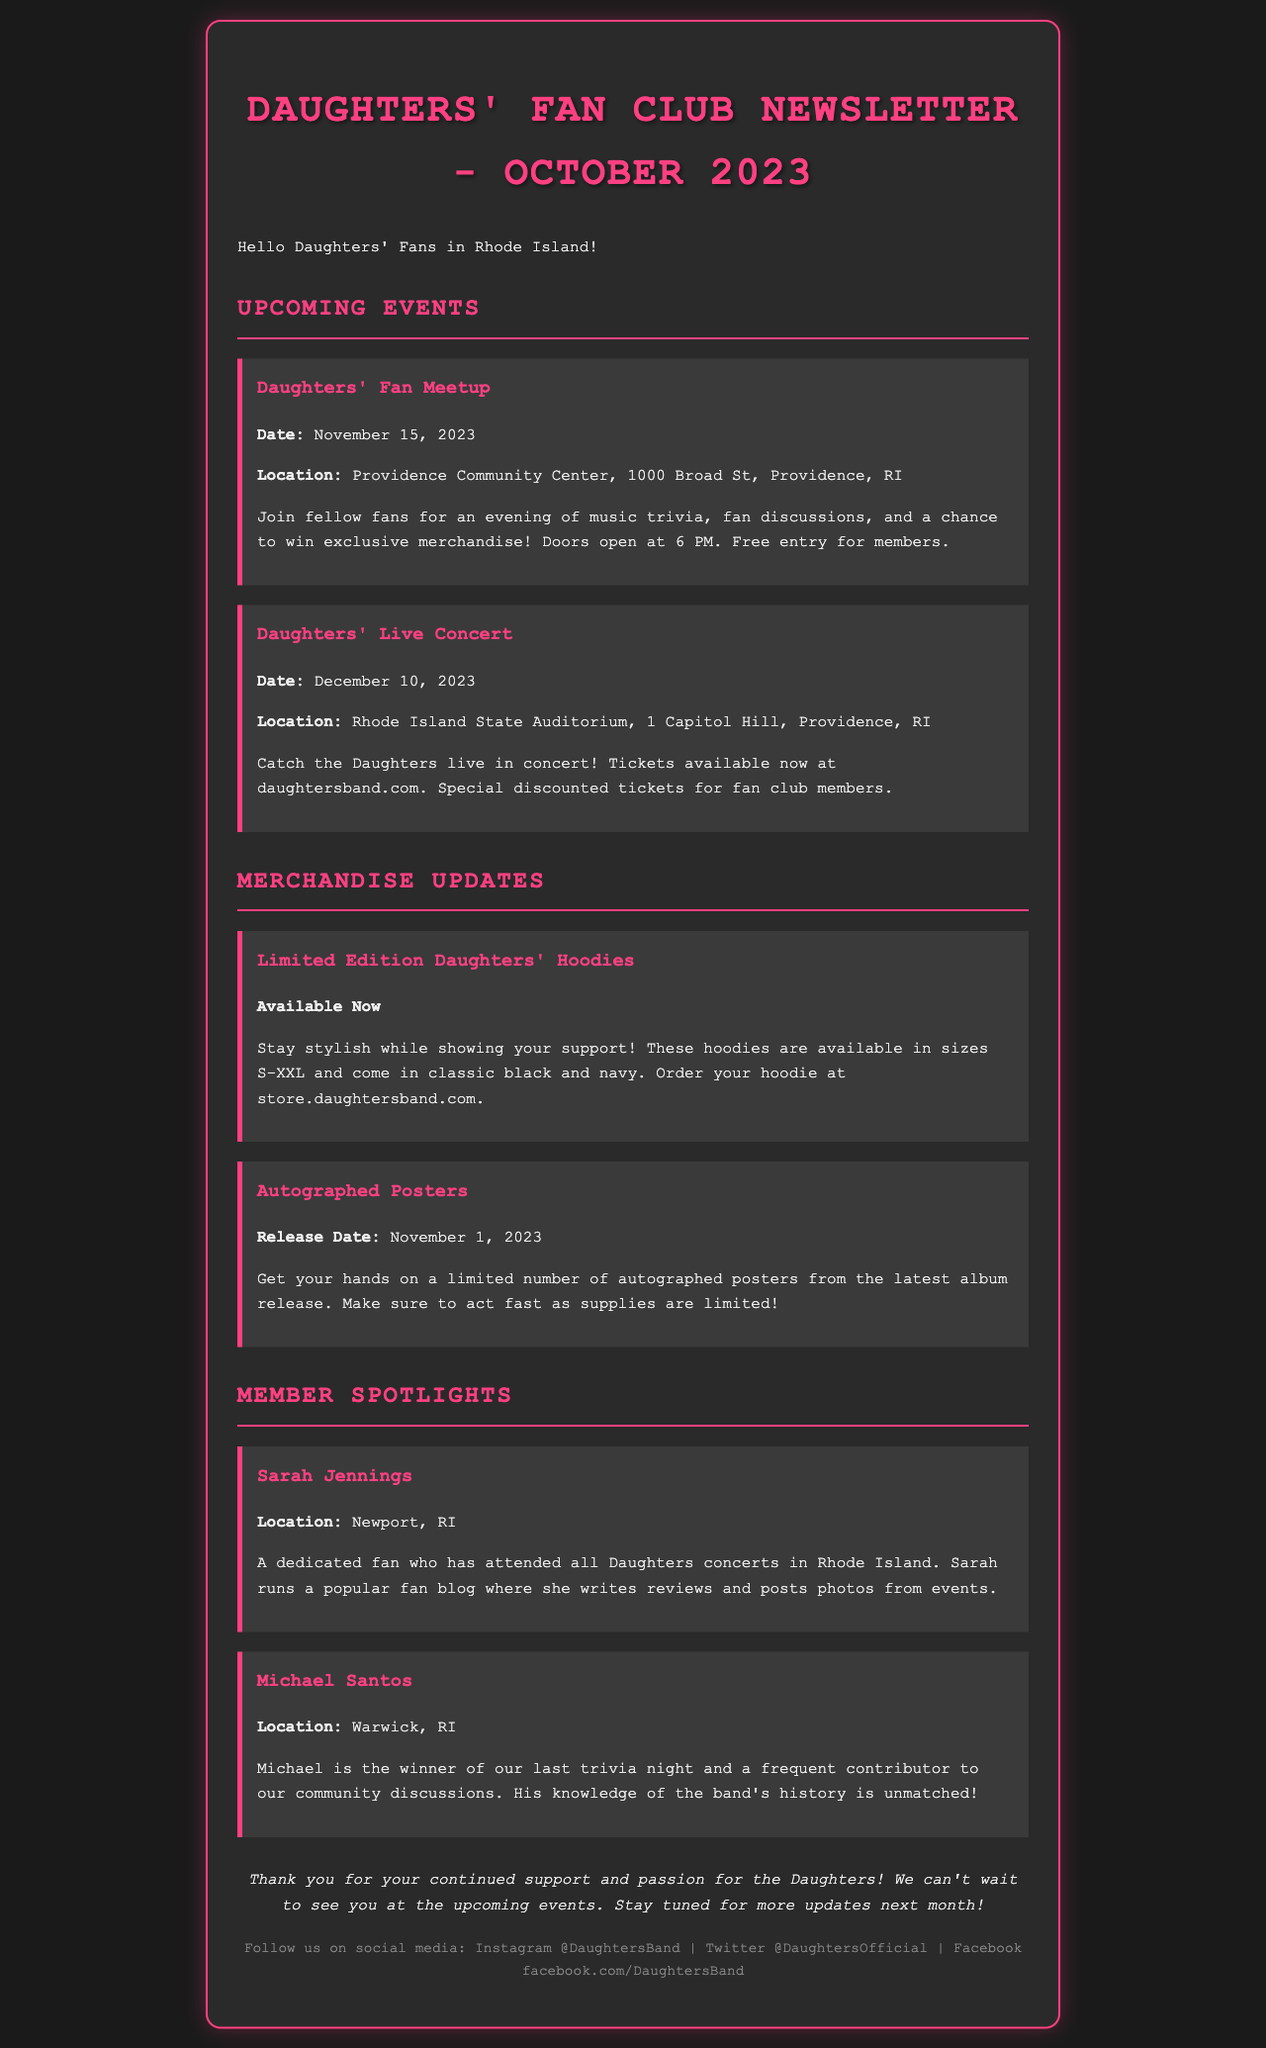what is the date of the Daughters' Fan Meetup? The date is explicitly mentioned in the upcoming events section of the document.
Answer: November 15, 2023 where is the Daughters' Live Concert located? The location is specified in the events section concerning the concert.
Answer: Rhode Island State Auditorium, 1 Capitol Hill, Providence, RI what merchandise is available now? The document lists merchandise updates, including items currently available for purchase.
Answer: Limited Edition Daughters' Hoodies who is featured in the member spotlight from Newport, RI? The document provides specific information about the members highlighted in the member spotlight section.
Answer: Sarah Jennings how many sizes are the hoodies available in? The number of sizes offered for the hoodies is mentioned in the merchandise updates.
Answer: S-XXL what special offer is available for fan club members at the concert? The concert information indicates a special offer for a specific group of fans.
Answer: Special discounted tickets who won the last trivia night? The document highlights achievements of certain fans in the member spotlight section.
Answer: Michael Santos how does the fan club communicate updates? The document mentions how the fan club keeps fans informed about events and updates.
Answer: Social media how often can members expect updates? The frequency of updates to the fans is mentioned in the closing section of the newsletter.
Answer: Next month 